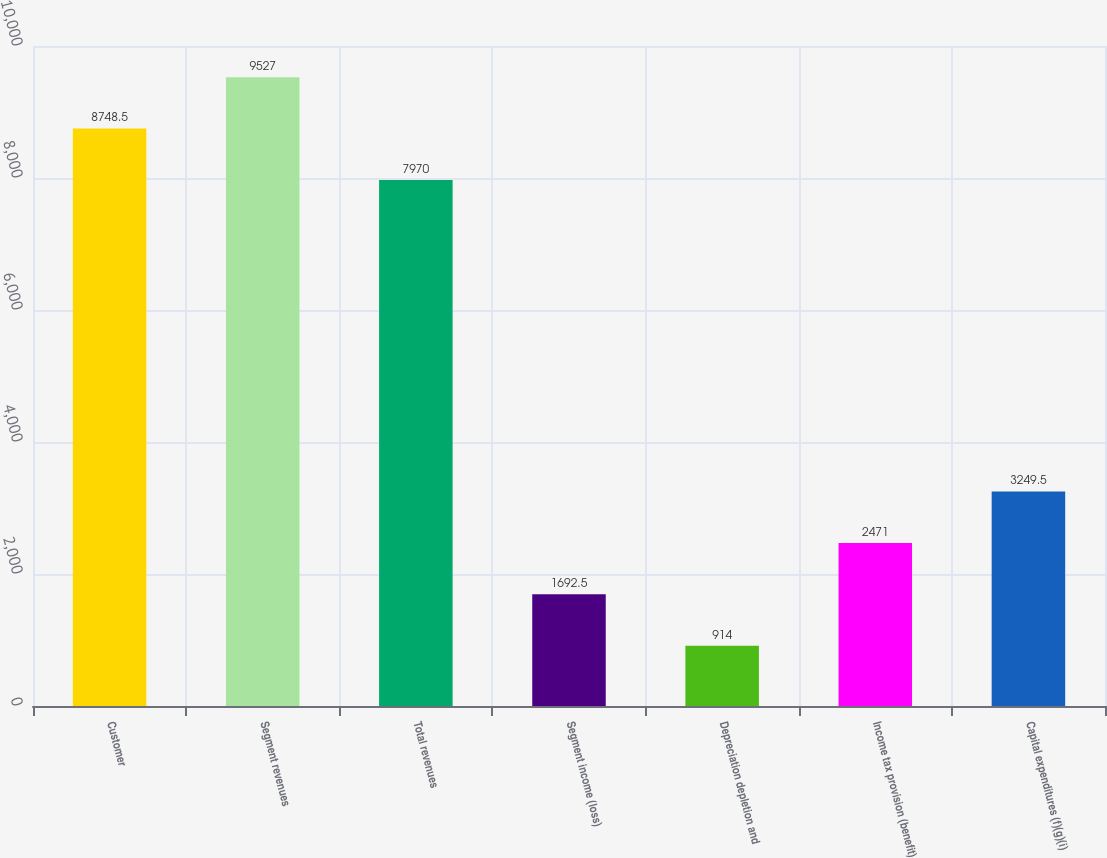Convert chart. <chart><loc_0><loc_0><loc_500><loc_500><bar_chart><fcel>Customer<fcel>Segment revenues<fcel>Total revenues<fcel>Segment income (loss)<fcel>Depreciation depletion and<fcel>Income tax provision (benefit)<fcel>Capital expenditures (f)(g)(i)<nl><fcel>8748.5<fcel>9527<fcel>7970<fcel>1692.5<fcel>914<fcel>2471<fcel>3249.5<nl></chart> 